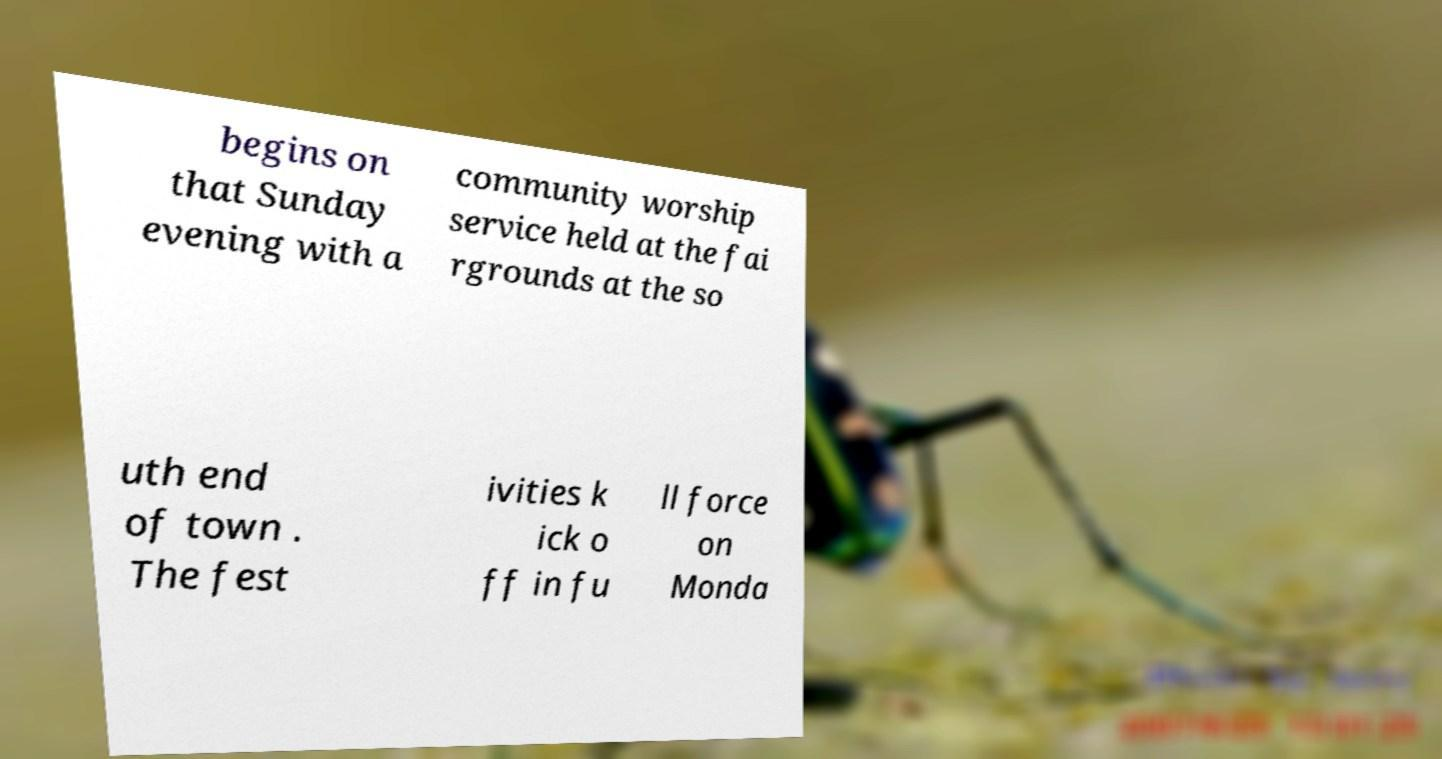Please identify and transcribe the text found in this image. begins on that Sunday evening with a community worship service held at the fai rgrounds at the so uth end of town . The fest ivities k ick o ff in fu ll force on Monda 